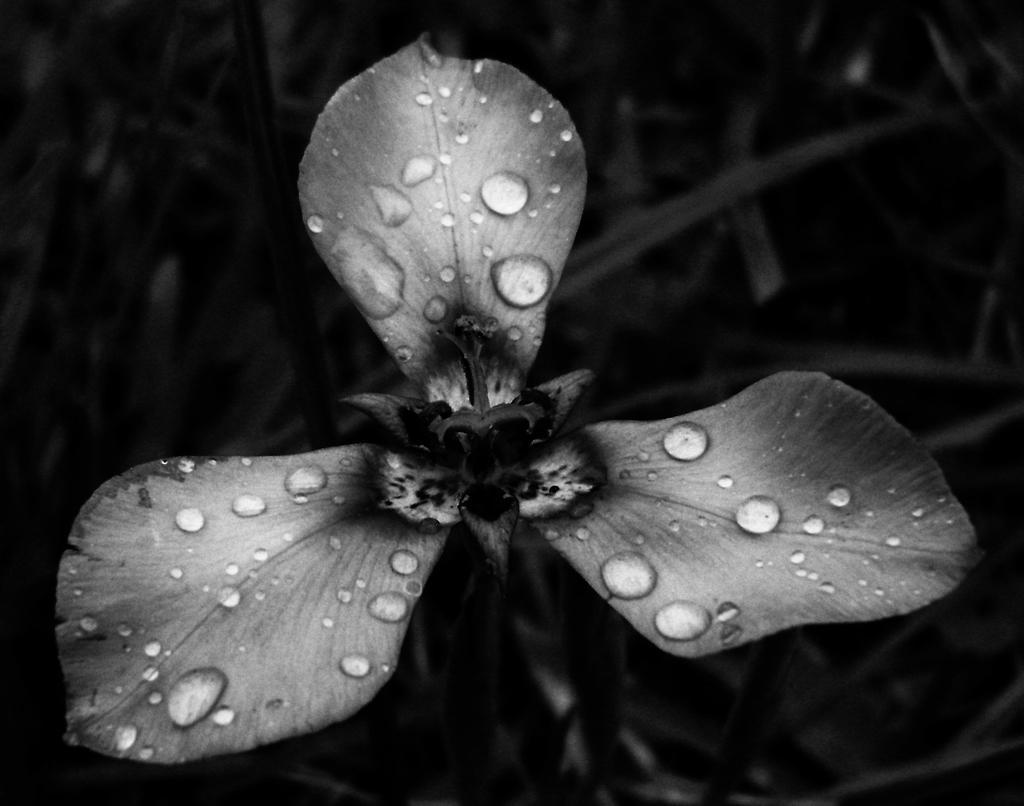Describe this image in one or two sentences. In this picture we can see a flower with water drops and in the background we can see plants. 